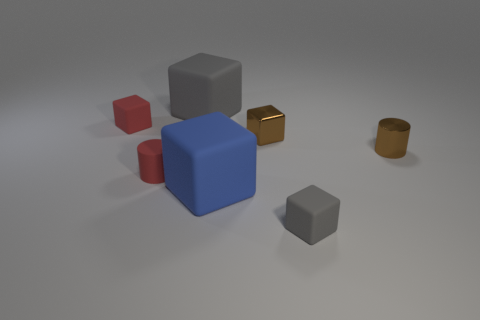How many things are purple metallic cubes or tiny red matte cubes?
Your answer should be very brief. 1. The red rubber cylinder is what size?
Offer a very short reply. Small. Are there fewer blue matte cubes than gray balls?
Your answer should be very brief. No. What number of tiny cubes have the same color as the tiny rubber cylinder?
Your answer should be very brief. 1. Does the cylinder to the right of the big gray rubber cube have the same color as the small metallic block?
Provide a short and direct response. Yes. What shape is the gray thing that is in front of the small brown cylinder?
Make the answer very short. Cube. Is there a tiny matte block behind the large thing that is in front of the tiny metal block?
Your response must be concise. Yes. How many large blue blocks have the same material as the small gray block?
Provide a short and direct response. 1. What is the size of the gray matte thing in front of the metallic object that is behind the tiny brown thing right of the tiny gray rubber thing?
Offer a terse response. Small. There is a blue matte thing; how many tiny matte cubes are on the left side of it?
Ensure brevity in your answer.  1. 